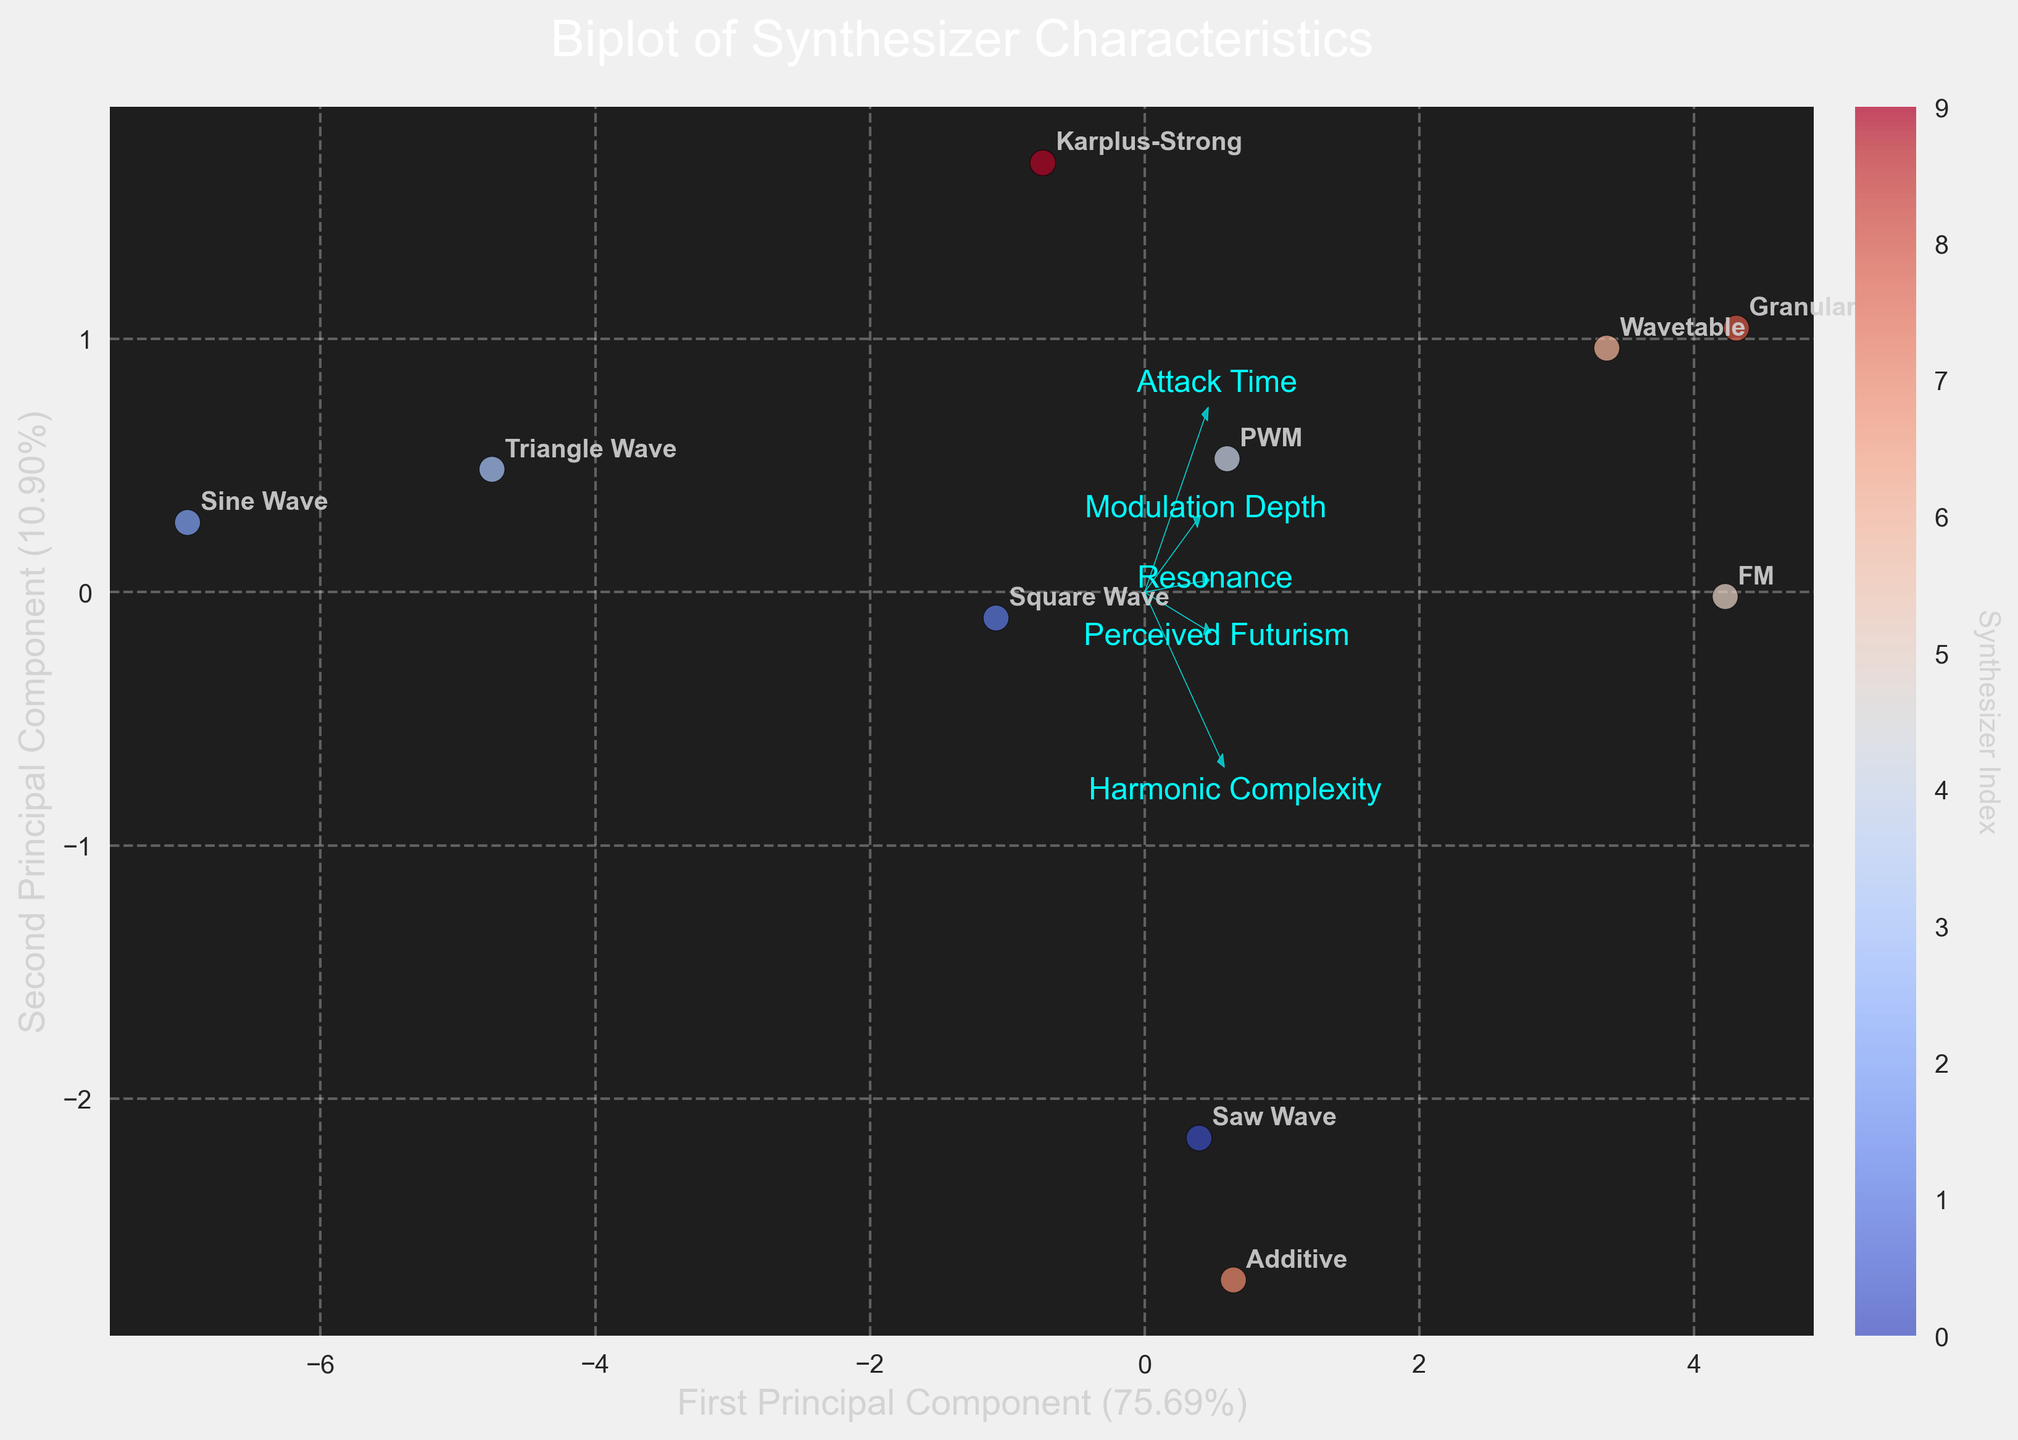Which synthesizer has the highest perceived futurism? The scatter plot shows the coordinates of each synthesizer by their principal components. By looking at the labels of each point, the synthesizer with the highest "Perceived Futurism" value is the one loftiest in the related axis.
Answer: FM Which feature vector has the longest arrow in the plot? In biplots, the length of the arrow shows the importance of the feature in the component. The feature vector with the longest arrow indicates the most significant attribute.
Answer: Harmonic Complexity How many synthesizer types are represented in the Biplot? Each label in the scatter plot represents a different synthesizer type. By counting the labels, we can determine the total number.
Answer: 10 Which feature corresponds to the arrow pointing most to the right? The direction of the arrows indicates the influence of each feature. The one pointing most to the right shows the feature that influences the first principal component the most.
Answer: Perceived Futurism Does the Wavetable synthesizer have a higher or lower principal component score than the Sine Wave in the second dimension? By comparing the y-coordinates (second principal component) of the Wavetable and Sine Wave labels, we can determine which one is higher.
Answer: Higher On which principal component does Modulation Depth have the strongest influence? The direction and length of the arrow indicate the influence. The arrow pointing more along a specific axis shows stronger influence on that component.
Answer: Second Principal Component Which synthesizer types are closest to each other in the Biplot? Look at the scatter plot for synthesizers that are positioned close together. This proximity indicates similarity in their waveform characteristics.
Answer: Saw Wave and PWM Is the first principal component more influenced by Attack Time or Resonance? The length and direction of the respective arrows will indicate which feature has a greater influence on the first principal component.
Answer: Resonance Which synthesizer is furthest from the origin on the second principal component? Locate the point with the highest or lowest y-coordinate, indicating its distance along the second principal component.
Answer: Granular Which two features appear to be most correlated based on their orientation? In biplots, features that have arrows pointing in the same direction are positively correlated. Find arrows that are most closely aligned.
Answer: Harmonic Complexity and Perceived Futurism 